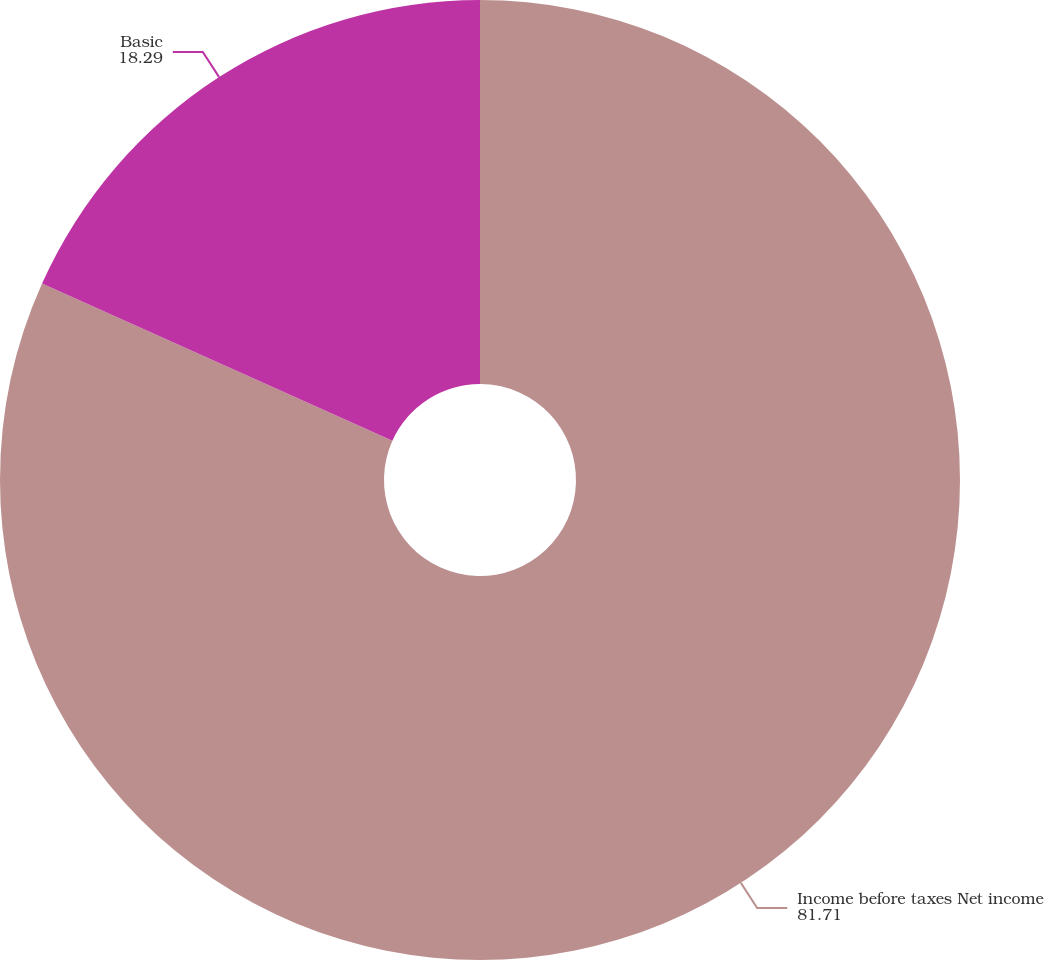Convert chart. <chart><loc_0><loc_0><loc_500><loc_500><pie_chart><fcel>Income before taxes Net income<fcel>Basic<nl><fcel>81.71%<fcel>18.29%<nl></chart> 